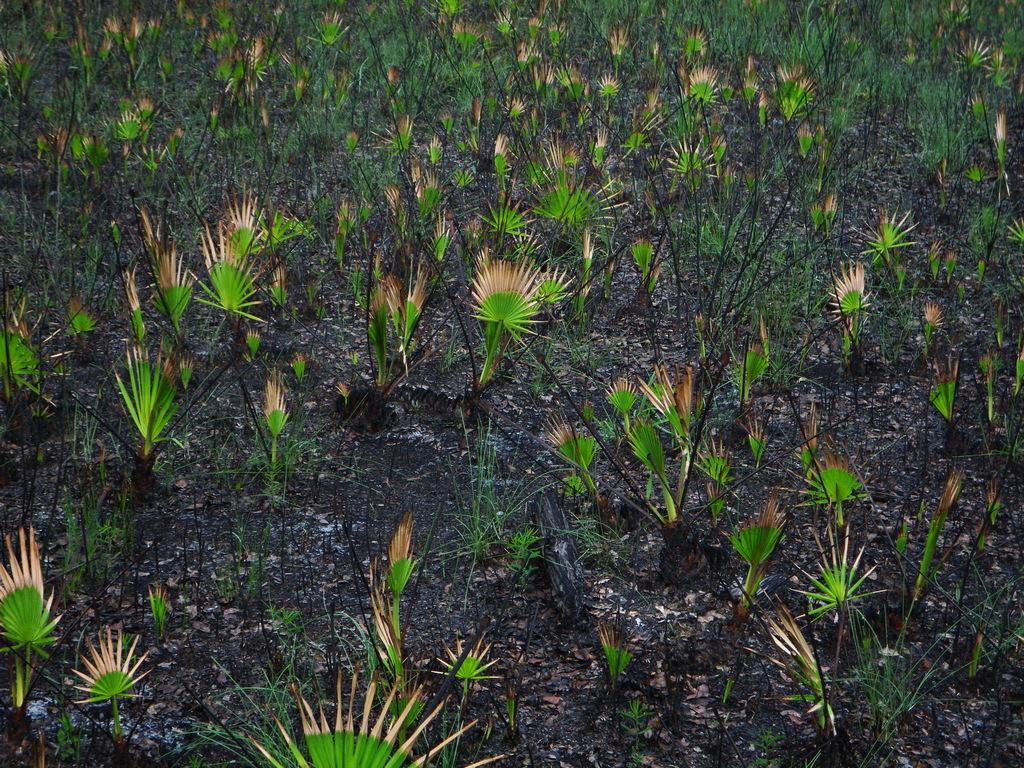What type of plants are in the image? There are green plants in the image. What can be seen beneath the plants in the image? There is soil visible in the image. What harmony is being played on the stage in the image? There is no stage or musical performance present in the image; it features green plants and soil. What book can be seen on the shelf in the image? There is no shelf or book present in the image; it only contains green plants and soil. 